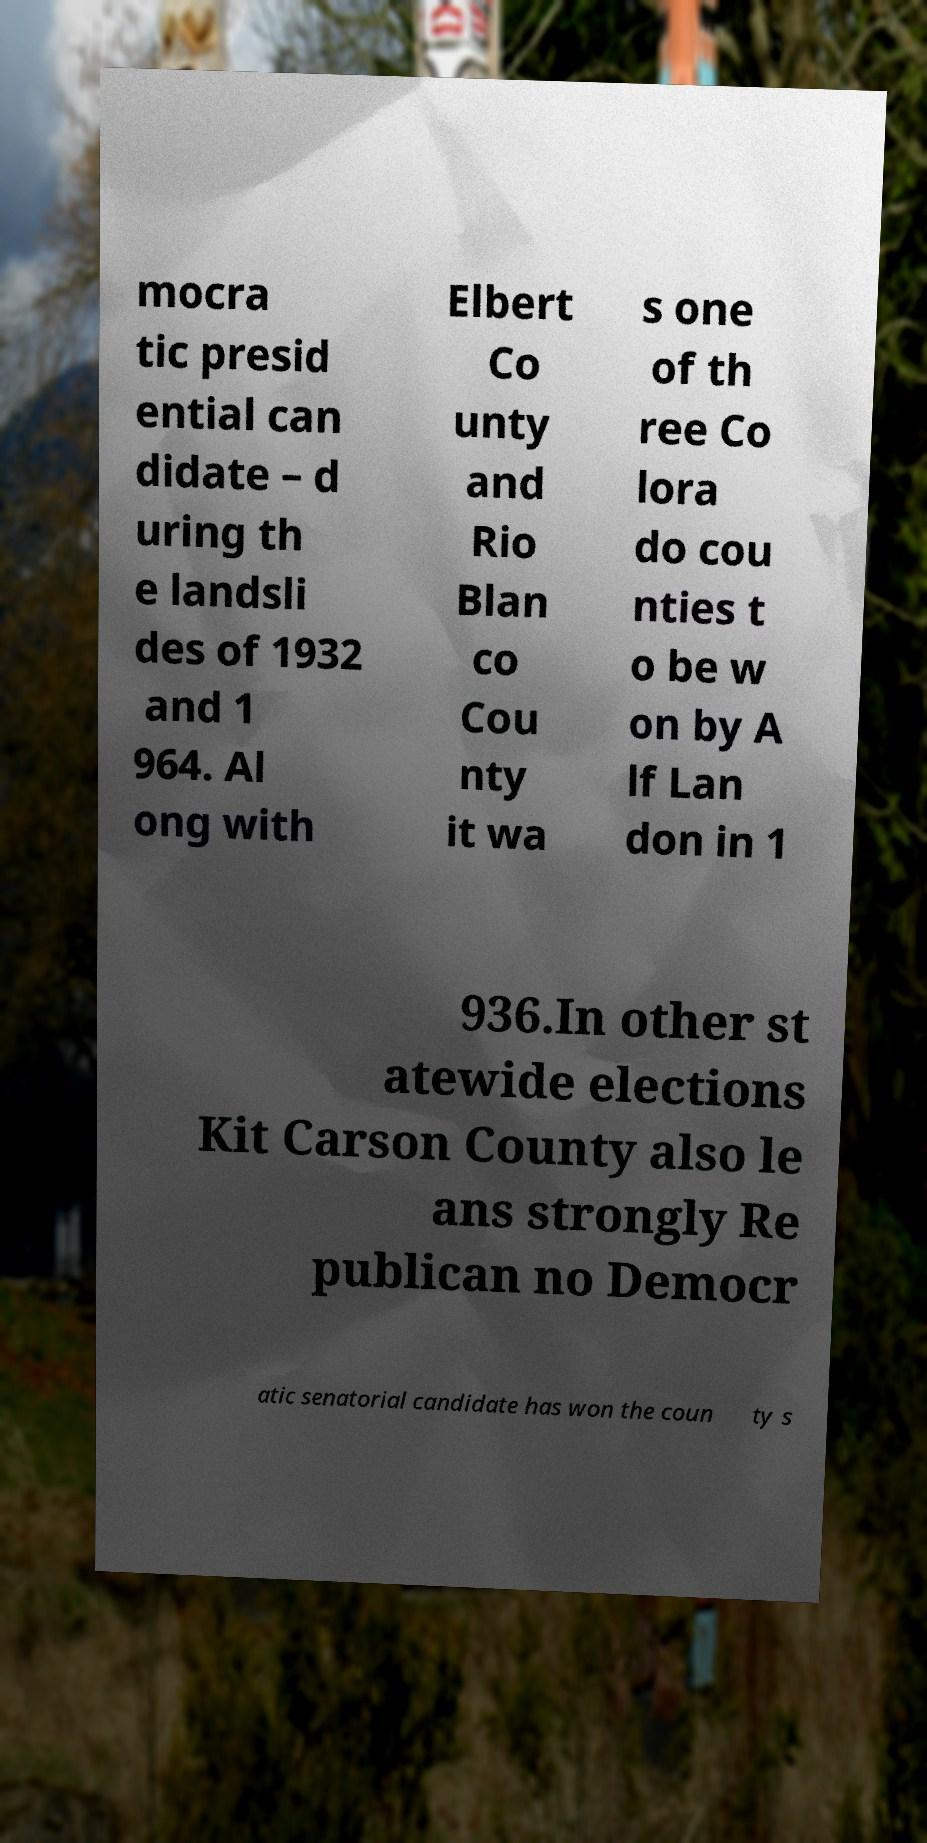Could you assist in decoding the text presented in this image and type it out clearly? mocra tic presid ential can didate – d uring th e landsli des of 1932 and 1 964. Al ong with Elbert Co unty and Rio Blan co Cou nty it wa s one of th ree Co lora do cou nties t o be w on by A lf Lan don in 1 936.In other st atewide elections Kit Carson County also le ans strongly Re publican no Democr atic senatorial candidate has won the coun ty s 